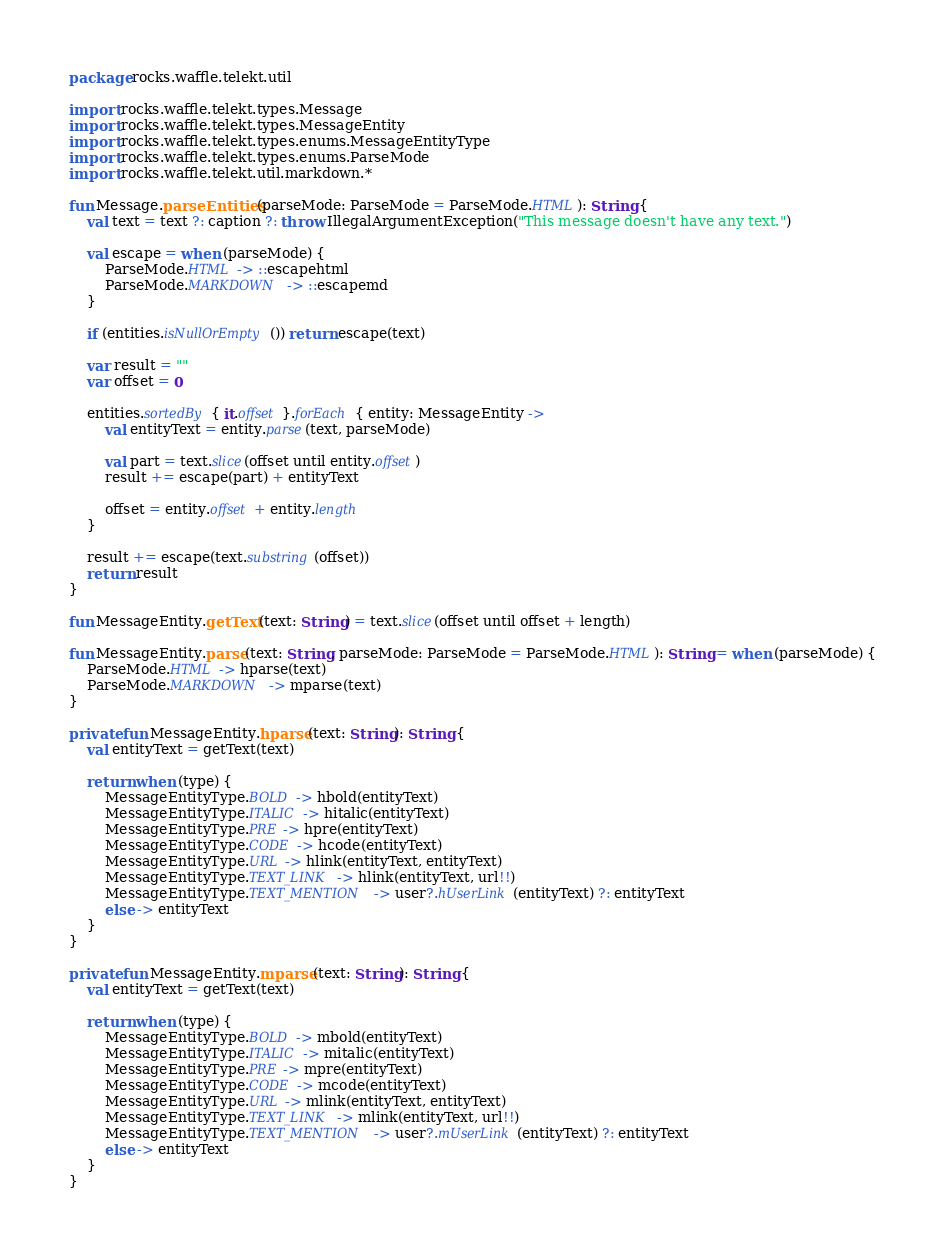<code> <loc_0><loc_0><loc_500><loc_500><_Kotlin_>package rocks.waffle.telekt.util

import rocks.waffle.telekt.types.Message
import rocks.waffle.telekt.types.MessageEntity
import rocks.waffle.telekt.types.enums.MessageEntityType
import rocks.waffle.telekt.types.enums.ParseMode
import rocks.waffle.telekt.util.markdown.*

fun Message.parseEntities(parseMode: ParseMode = ParseMode.HTML): String {
    val text = text ?: caption ?: throw IllegalArgumentException("This message doesn't have any text.")

    val escape = when (parseMode) {
        ParseMode.HTML -> ::escapehtml
        ParseMode.MARKDOWN -> ::escapemd
    }

    if (entities.isNullOrEmpty()) return escape(text)

    var result = ""
    var offset = 0

    entities.sortedBy { it.offset }.forEach { entity: MessageEntity ->
        val entityText = entity.parse(text, parseMode)

        val part = text.slice(offset until entity.offset)
        result += escape(part) + entityText

        offset = entity.offset + entity.length
    }

    result += escape(text.substring(offset))
    return result
}

fun MessageEntity.getText(text: String) = text.slice(offset until offset + length)

fun MessageEntity.parse(text: String, parseMode: ParseMode = ParseMode.HTML): String = when (parseMode) {
    ParseMode.HTML -> hparse(text)
    ParseMode.MARKDOWN -> mparse(text)
}

private fun MessageEntity.hparse(text: String): String {
    val entityText = getText(text)

    return when (type) {
        MessageEntityType.BOLD -> hbold(entityText)
        MessageEntityType.ITALIC -> hitalic(entityText)
        MessageEntityType.PRE -> hpre(entityText)
        MessageEntityType.CODE -> hcode(entityText)
        MessageEntityType.URL -> hlink(entityText, entityText)
        MessageEntityType.TEXT_LINK -> hlink(entityText, url!!)
        MessageEntityType.TEXT_MENTION -> user?.hUserLink(entityText) ?: entityText
        else -> entityText
    }
}

private fun MessageEntity.mparse(text: String): String {
    val entityText = getText(text)

    return when (type) {
        MessageEntityType.BOLD -> mbold(entityText)
        MessageEntityType.ITALIC -> mitalic(entityText)
        MessageEntityType.PRE -> mpre(entityText)
        MessageEntityType.CODE -> mcode(entityText)
        MessageEntityType.URL -> mlink(entityText, entityText)
        MessageEntityType.TEXT_LINK -> mlink(entityText, url!!)
        MessageEntityType.TEXT_MENTION -> user?.mUserLink(entityText) ?: entityText
        else -> entityText
    }
}</code> 